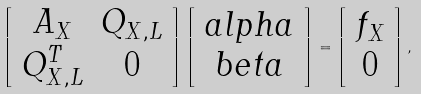<formula> <loc_0><loc_0><loc_500><loc_500>\left [ \begin{array} { c c } A _ { X } & Q _ { X , L } \\ Q _ { X , L } ^ { T } & 0 \end{array} \right ] \left [ \begin{array} { c } { a l p h a } \\ { b e t a } \end{array} \right ] = \left [ \begin{array} { c } { f } _ { X } \\ { 0 } \end{array} \right ] ,</formula> 